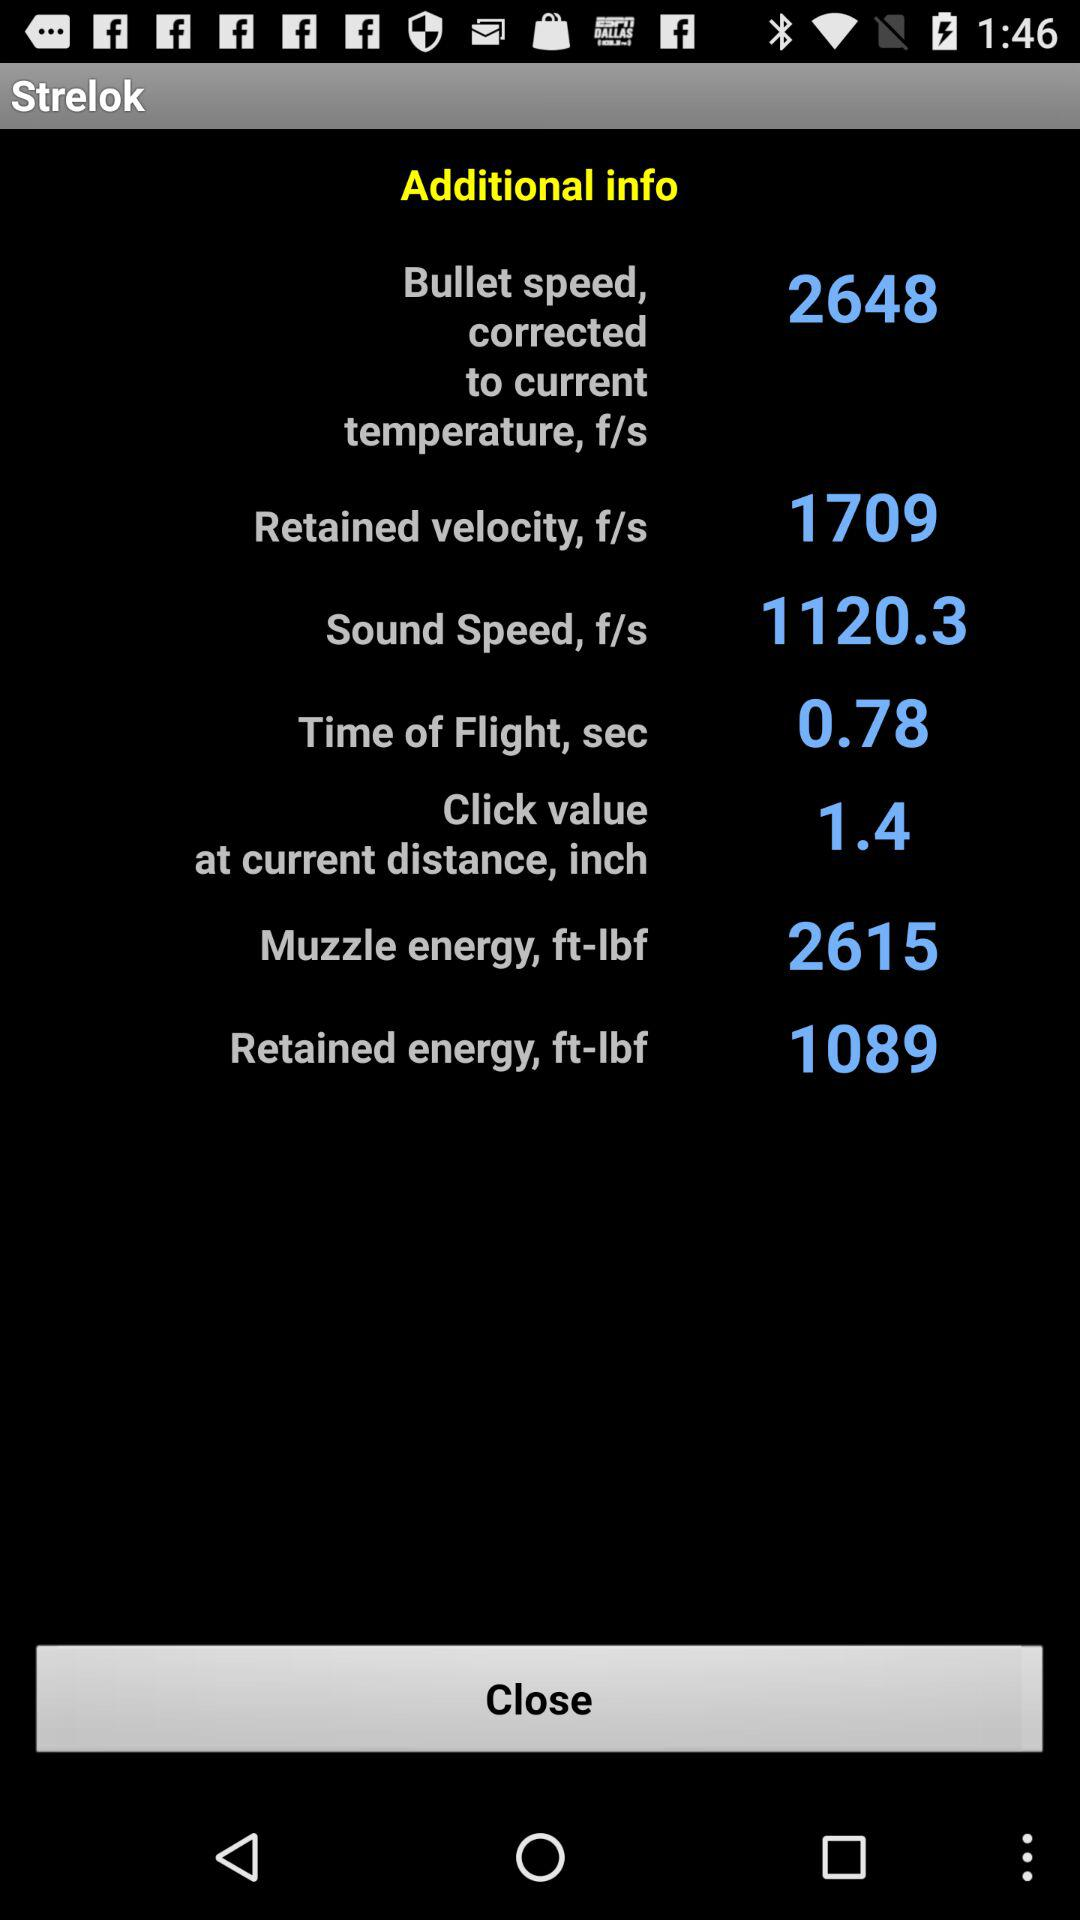What is the retained energy? The retained energy is 1089. 